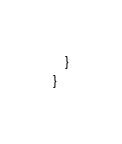<code> <loc_0><loc_0><loc_500><loc_500><_Java_>    }
}
</code> 